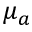<formula> <loc_0><loc_0><loc_500><loc_500>\mu _ { a }</formula> 